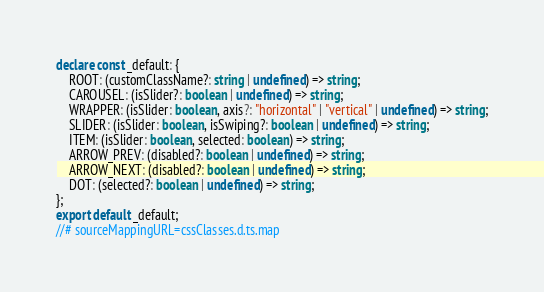Convert code to text. <code><loc_0><loc_0><loc_500><loc_500><_TypeScript_>declare const _default: {
    ROOT: (customClassName?: string | undefined) => string;
    CAROUSEL: (isSlider?: boolean | undefined) => string;
    WRAPPER: (isSlider: boolean, axis?: "horizontal" | "vertical" | undefined) => string;
    SLIDER: (isSlider: boolean, isSwiping?: boolean | undefined) => string;
    ITEM: (isSlider: boolean, selected: boolean) => string;
    ARROW_PREV: (disabled?: boolean | undefined) => string;
    ARROW_NEXT: (disabled?: boolean | undefined) => string;
    DOT: (selected?: boolean | undefined) => string;
};
export default _default;
//# sourceMappingURL=cssClasses.d.ts.map</code> 